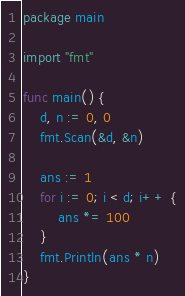<code> <loc_0><loc_0><loc_500><loc_500><_Go_>package main

import "fmt"

func main() {
	d, n := 0, 0
	fmt.Scan(&d, &n)

	ans := 1
	for i := 0; i < d; i++ {
		ans *= 100
	}
	fmt.Println(ans * n)
}
</code> 